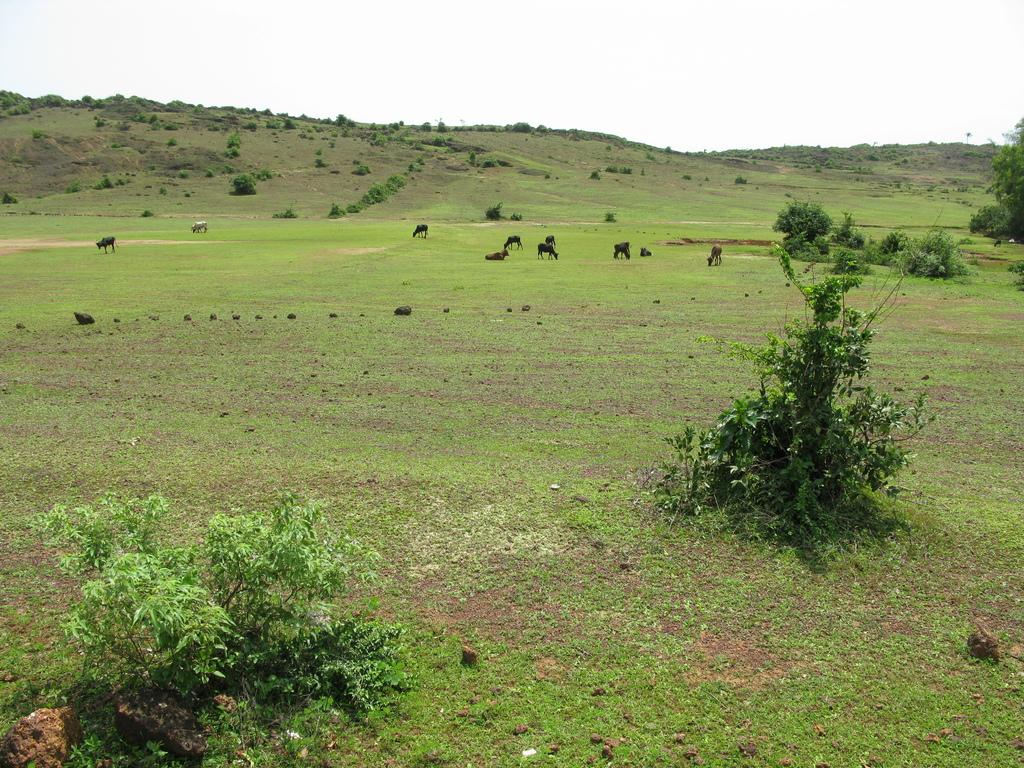What is visible in the foreground of the image? There is grass and plants in the foreground of the image. What can be seen on the ground in the background of the image? There are animals on the ground in the background of the image. What types of vegetation are present in the background of the image? There are plants, trees, and shrubs on the slope ground in the background of the image. What part of the natural environment is visible in the background of the image? The sky is visible in the background of the image. What impulse can be seen affecting the plants in the image? There is no impulse affecting the plants in the image; they are stationary. Is there a fire visible in the image? No, there is no fire present in the image. 